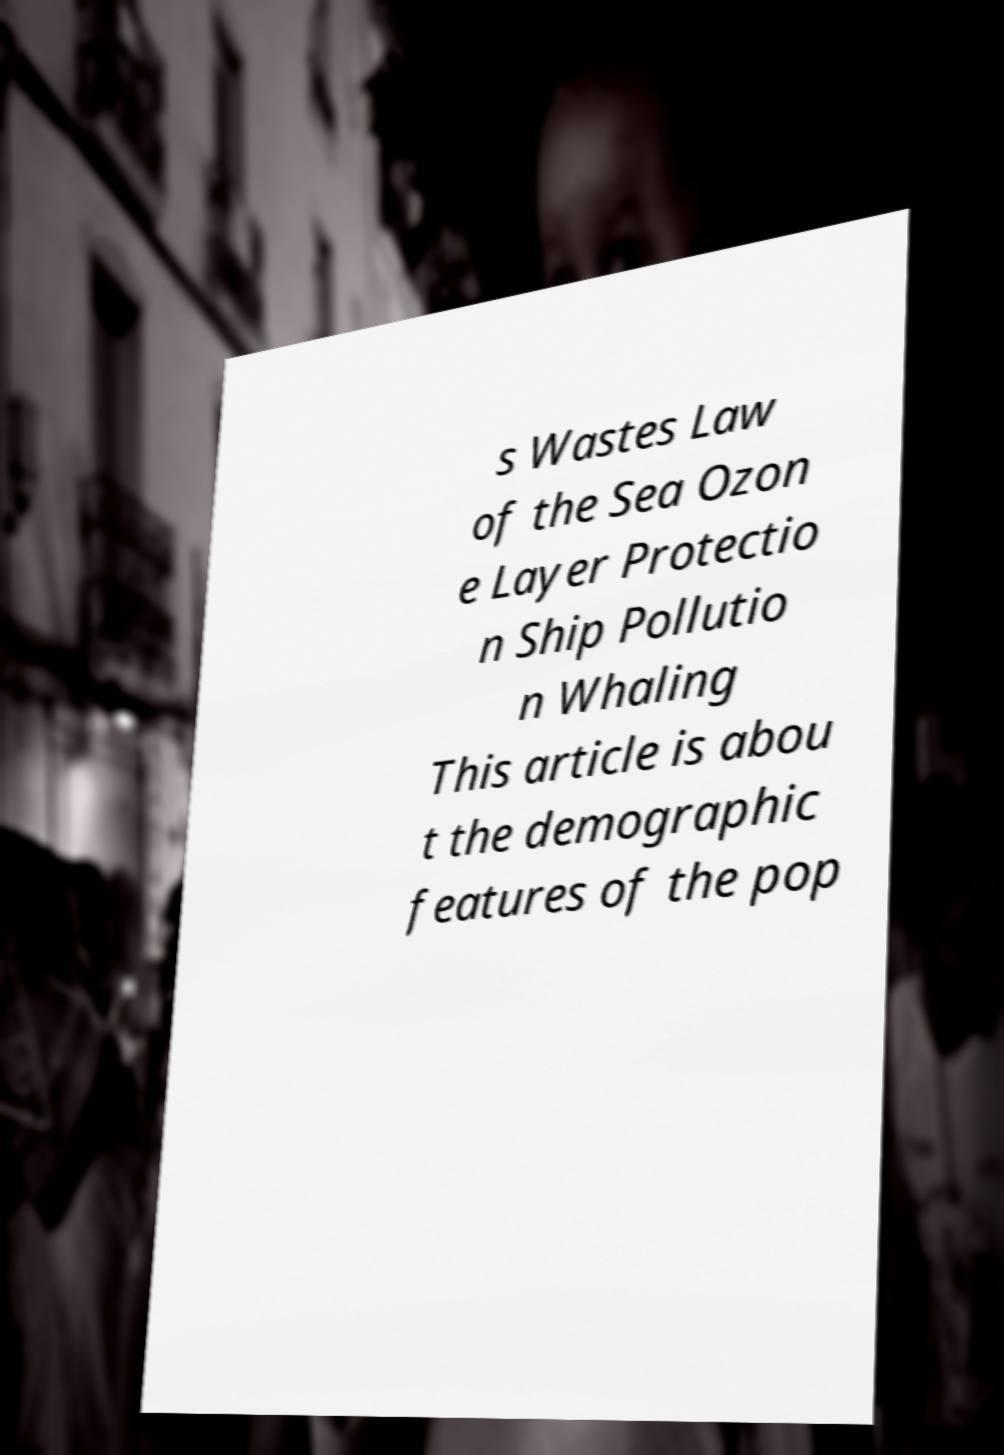There's text embedded in this image that I need extracted. Can you transcribe it verbatim? s Wastes Law of the Sea Ozon e Layer Protectio n Ship Pollutio n Whaling This article is abou t the demographic features of the pop 